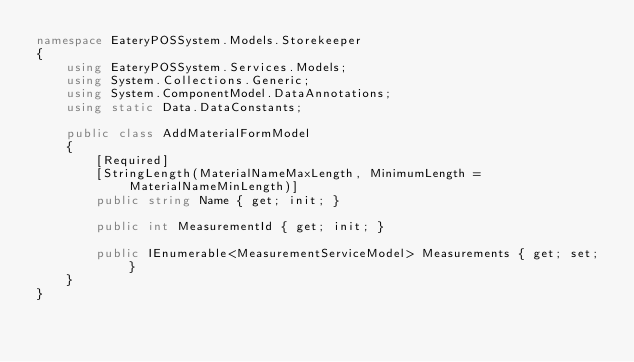<code> <loc_0><loc_0><loc_500><loc_500><_C#_>namespace EateryPOSSystem.Models.Storekeeper
{
    using EateryPOSSystem.Services.Models;
    using System.Collections.Generic;
    using System.ComponentModel.DataAnnotations;
    using static Data.DataConstants;

    public class AddMaterialFormModel
    {
        [Required]
        [StringLength(MaterialNameMaxLength, MinimumLength = MaterialNameMinLength)]
        public string Name { get; init; }

        public int MeasurementId { get; init; }

        public IEnumerable<MeasurementServiceModel> Measurements { get; set; }
    }
}
</code> 